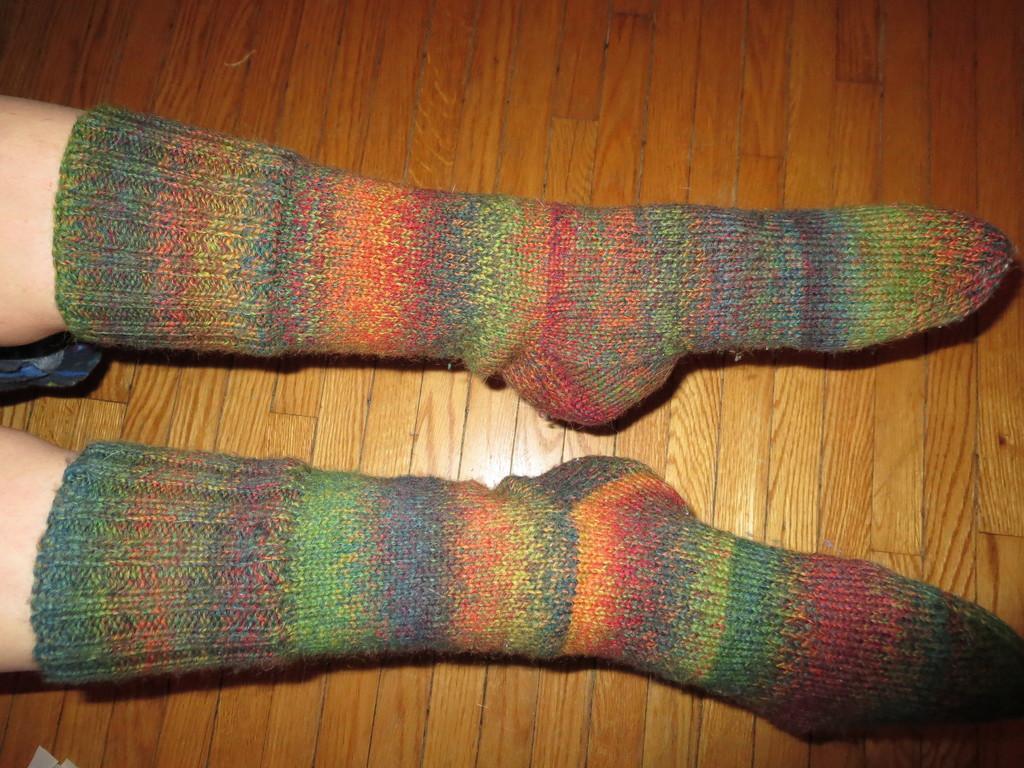Can you describe this image briefly? In this picture we can see the boy leg with colorful socks seen on the wooden flooring. 